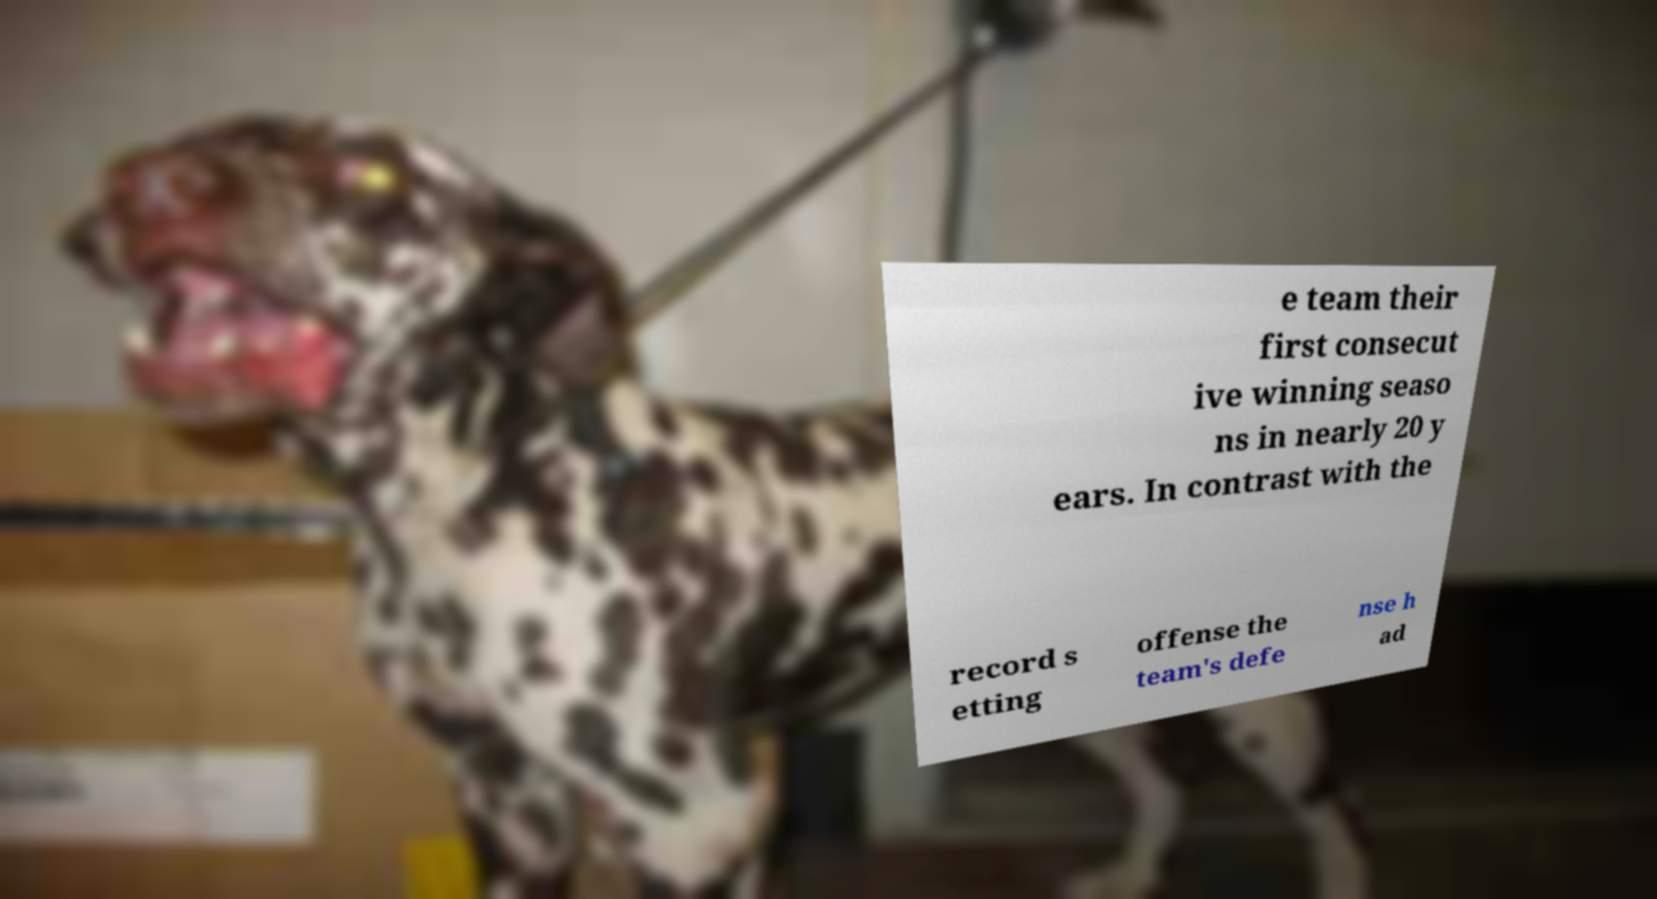I need the written content from this picture converted into text. Can you do that? e team their first consecut ive winning seaso ns in nearly 20 y ears. In contrast with the record s etting offense the team's defe nse h ad 